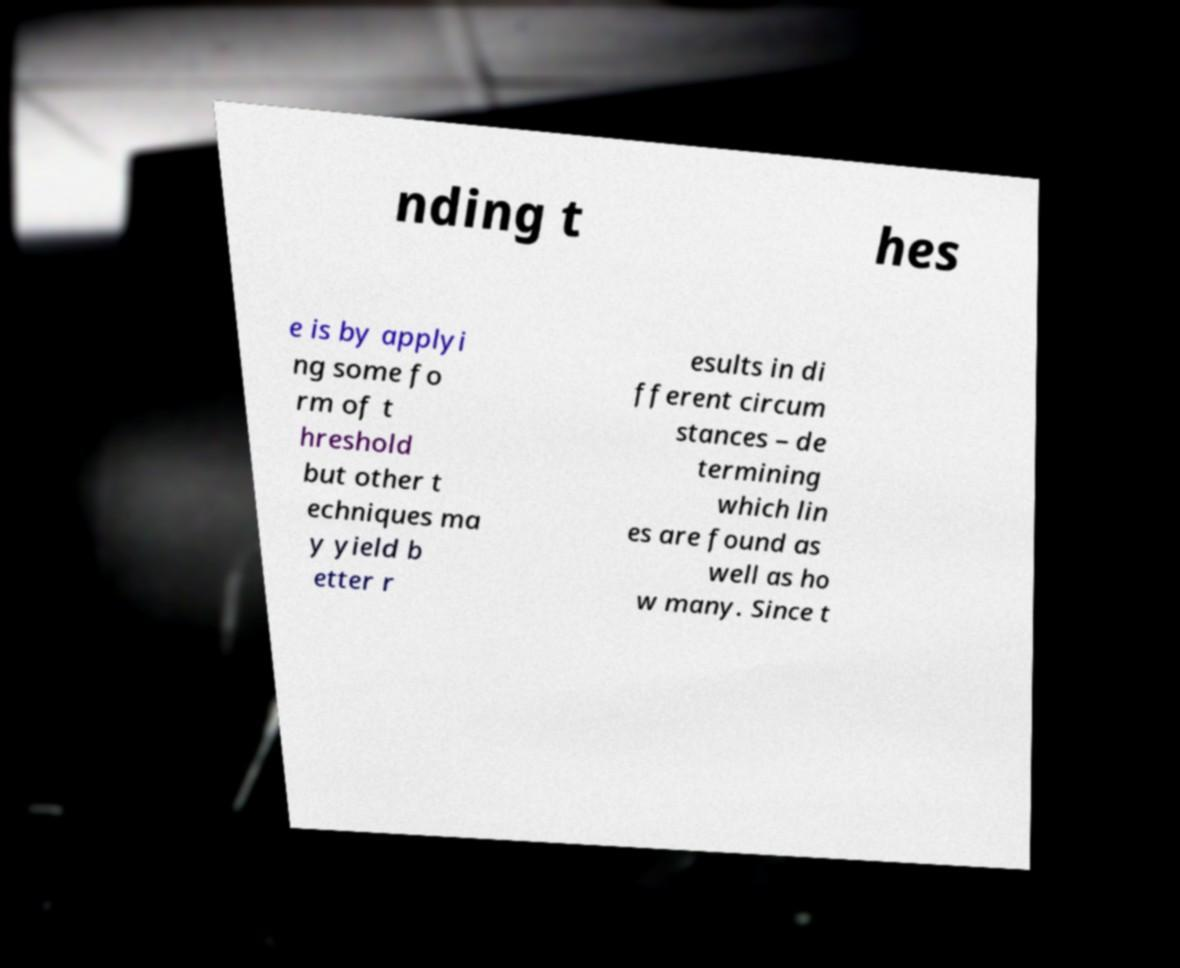Could you assist in decoding the text presented in this image and type it out clearly? nding t hes e is by applyi ng some fo rm of t hreshold but other t echniques ma y yield b etter r esults in di fferent circum stances – de termining which lin es are found as well as ho w many. Since t 